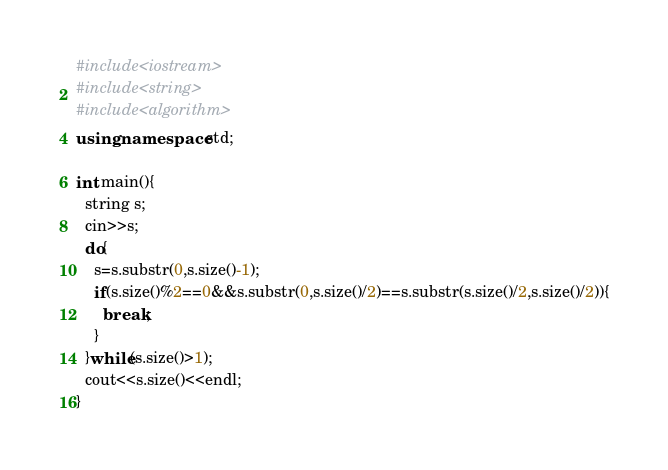<code> <loc_0><loc_0><loc_500><loc_500><_C++_>#include<iostream>
#include<string>
#include<algorithm>
using namespace std;

int main(){
  string s;
  cin>>s;
  do{
    s=s.substr(0,s.size()-1);
    if(s.size()%2==0&&s.substr(0,s.size()/2)==s.substr(s.size()/2,s.size()/2)){
      break;
    }
  }while(s.size()>1);
  cout<<s.size()<<endl;
}</code> 